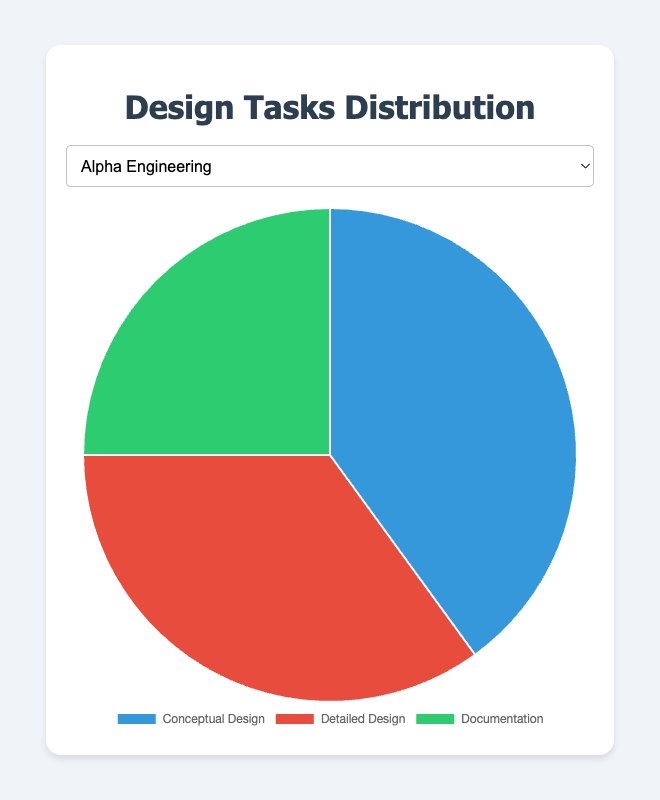What percentage of tasks does Alpha Engineering allocate to Detailed Design and Documentation combined? To find this, add the percentage for Detailed Design (35%) and Documentation (25%). 35% + 25% = 60%
Answer: 60% Which team has the highest percentage allocation for Conceptual Design? Compare the Conceptual Design percentages of all teams: Alpha Engineering (40%), Beta Design Works (45%), Gamma Innovations (50%), Delta Precision (35%), Epsilon Studios (55%). Epsilon Studios has the highest percentage at 55%.
Answer: Epsilon Studios How does Delta Precision's Detailed Design allocation compare to Gamma Innovations’ Detailed Design allocation? Delta Precision allocates 40% to Detailed Design while Gamma Innovations allocates 30%. 40% is greater than 30%.
Answer: Delta Precision allocates more What is the difference in Conceptual Design allocation between Beta Design Works and Epsilon Studios? Subtract Beta Design Works’s percentage for Conceptual Design (45%) from Epsilon Studios’s (55%). 55% - 45% = 10%
Answer: 10% If you combine all the teams' Documentation percentages, what is the total? Sum the Documentation percentages: 25% (Alpha Engineering) + 25% (Beta Design Works) + 20% (Gamma Innovations) + 25% (Delta Precision) + 20% (Epsilon Studios). 25% + 25% + 20% + 25% + 20% = 115%
Answer: 115% Between which two teams is the smallest difference in Conceptual Design allocation? Calculate differences in Conceptual Design: Alpha Engineering (40%) and Beta Design Works (45%) differ by 5%, Alpha Engineering and Delta Precision (35%) differ by 5%, and Beta Design Works and Gamma Innovations (50%) differ by 5%. All these pairs have a difference of 5%. The smallest difference is 5%.
Answer: Alpha Engineering - Beta Design Works Which task has the smallest allocation in Gamma Innovations? Compare the percentages: Conceptual Design (50%), Detailed Design (30%), and Documentation (20%). Documentation has the smallest allocation at 20%.
Answer: Documentation What is the average percentage allocation for Detailed Design across all teams? Add all Detailed Design percentages, then divide by the number of teams: (35% + 30% + 30% + 40% + 25%) / 5. (35% + 30% + 30% + 40% + 25%) = 160%. 160% / 5 = 32%
Answer: 32% 